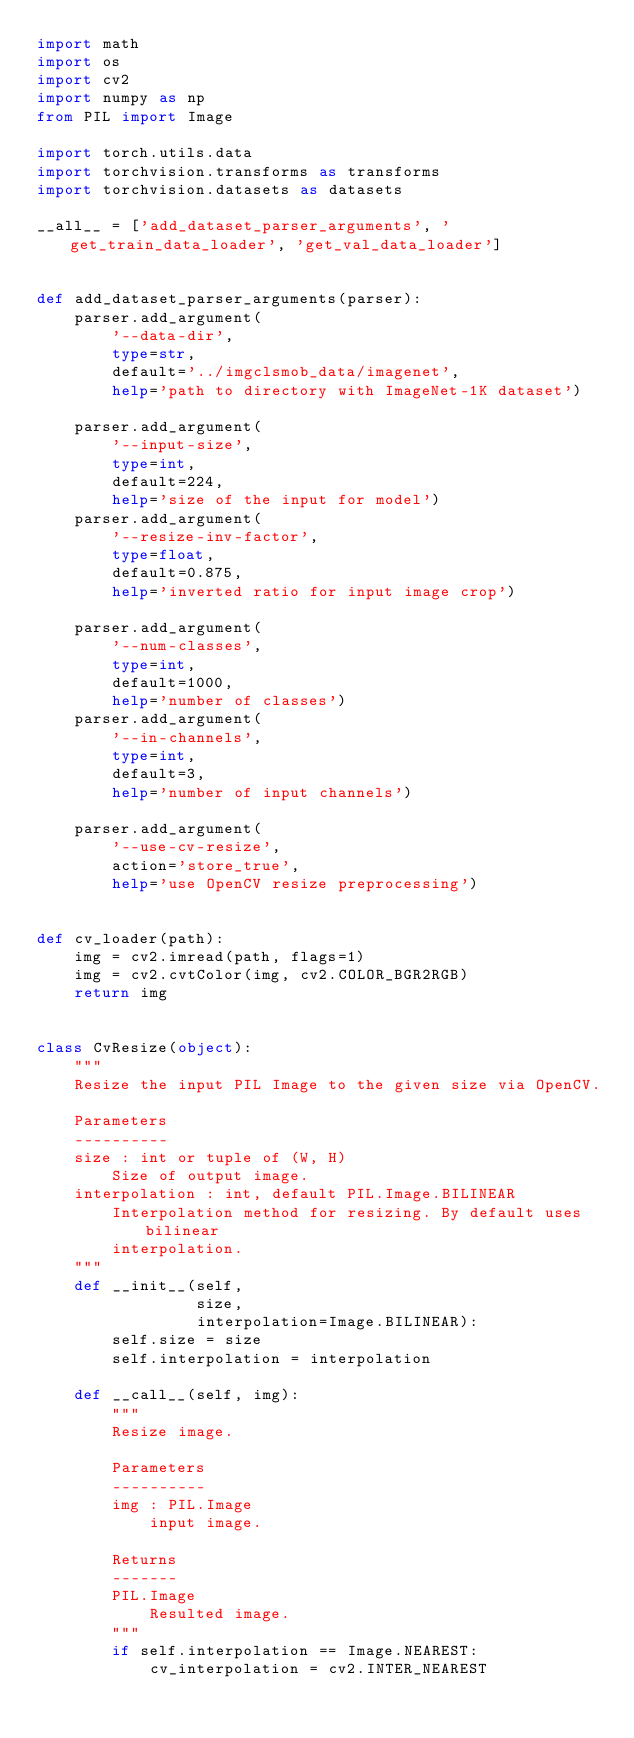Convert code to text. <code><loc_0><loc_0><loc_500><loc_500><_Python_>import math
import os
import cv2
import numpy as np
from PIL import Image

import torch.utils.data
import torchvision.transforms as transforms
import torchvision.datasets as datasets

__all__ = ['add_dataset_parser_arguments', 'get_train_data_loader', 'get_val_data_loader']


def add_dataset_parser_arguments(parser):
    parser.add_argument(
        '--data-dir',
        type=str,
        default='../imgclsmob_data/imagenet',
        help='path to directory with ImageNet-1K dataset')

    parser.add_argument(
        '--input-size',
        type=int,
        default=224,
        help='size of the input for model')
    parser.add_argument(
        '--resize-inv-factor',
        type=float,
        default=0.875,
        help='inverted ratio for input image crop')

    parser.add_argument(
        '--num-classes',
        type=int,
        default=1000,
        help='number of classes')
    parser.add_argument(
        '--in-channels',
        type=int,
        default=3,
        help='number of input channels')

    parser.add_argument(
        '--use-cv-resize',
        action='store_true',
        help='use OpenCV resize preprocessing')


def cv_loader(path):
    img = cv2.imread(path, flags=1)
    img = cv2.cvtColor(img, cv2.COLOR_BGR2RGB)
    return img


class CvResize(object):
    """
    Resize the input PIL Image to the given size via OpenCV.

    Parameters
    ----------
    size : int or tuple of (W, H)
        Size of output image.
    interpolation : int, default PIL.Image.BILINEAR
        Interpolation method for resizing. By default uses bilinear
        interpolation.
    """
    def __init__(self,
                 size,
                 interpolation=Image.BILINEAR):
        self.size = size
        self.interpolation = interpolation

    def __call__(self, img):
        """
        Resize image.

        Parameters
        ----------
        img : PIL.Image
            input image.

        Returns
        -------
        PIL.Image
            Resulted image.
        """
        if self.interpolation == Image.NEAREST:
            cv_interpolation = cv2.INTER_NEAREST</code> 